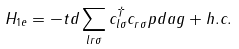Convert formula to latex. <formula><loc_0><loc_0><loc_500><loc_500>H _ { 1 e } = - t d \sum _ { l r \sigma } c _ { l \sigma } ^ { \dagger } c _ { r \sigma } ^ { \ } p d a g + h . c .</formula> 